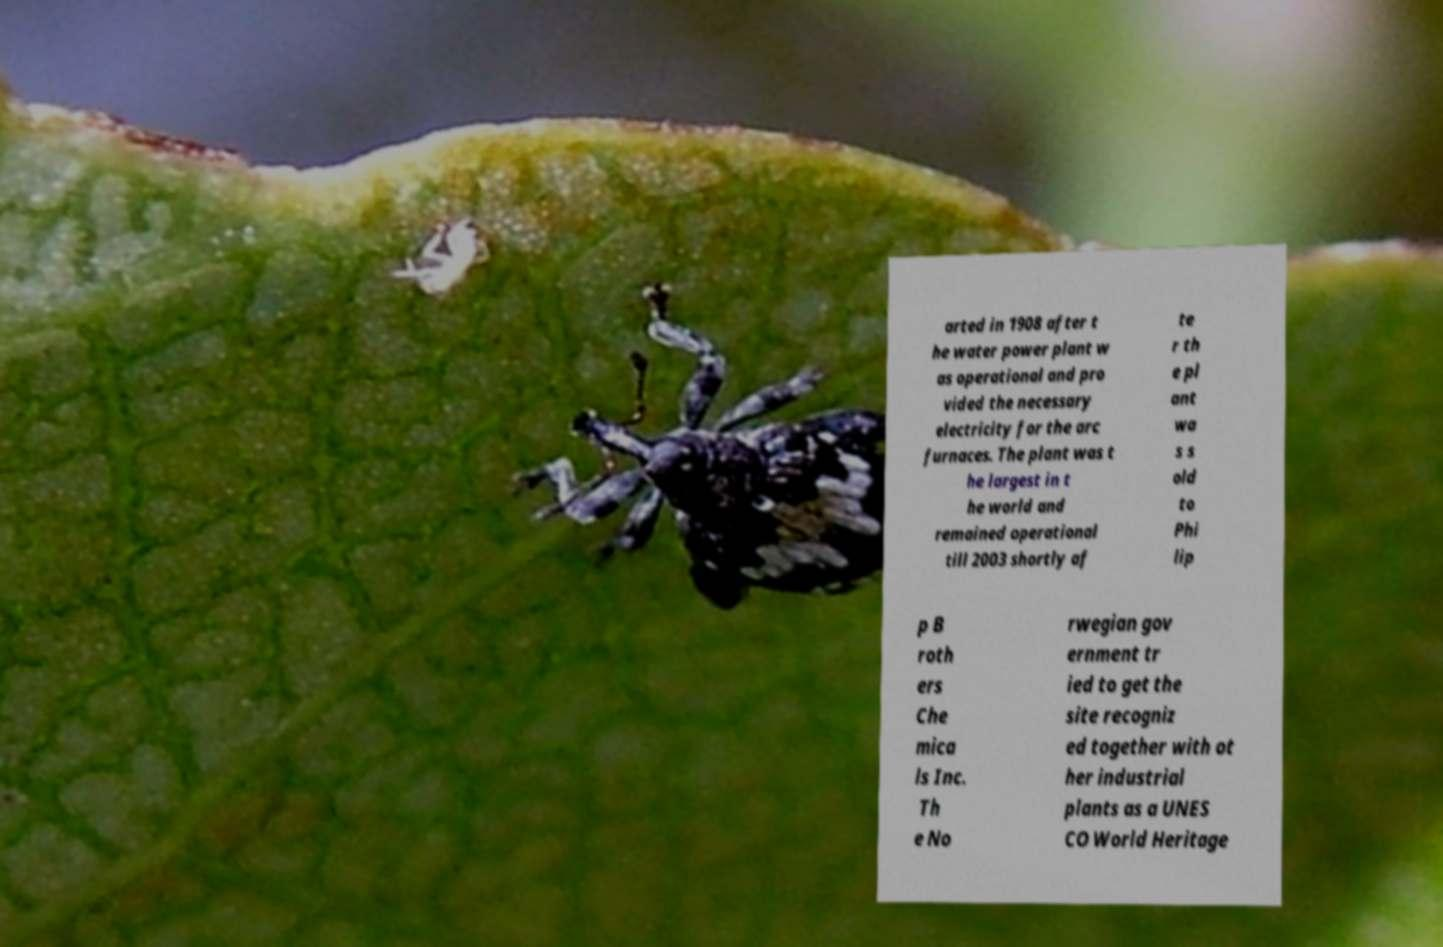Can you read and provide the text displayed in the image?This photo seems to have some interesting text. Can you extract and type it out for me? arted in 1908 after t he water power plant w as operational and pro vided the necessary electricity for the arc furnaces. The plant was t he largest in t he world and remained operational till 2003 shortly af te r th e pl ant wa s s old to Phi lip p B roth ers Che mica ls Inc. Th e No rwegian gov ernment tr ied to get the site recogniz ed together with ot her industrial plants as a UNES CO World Heritage 